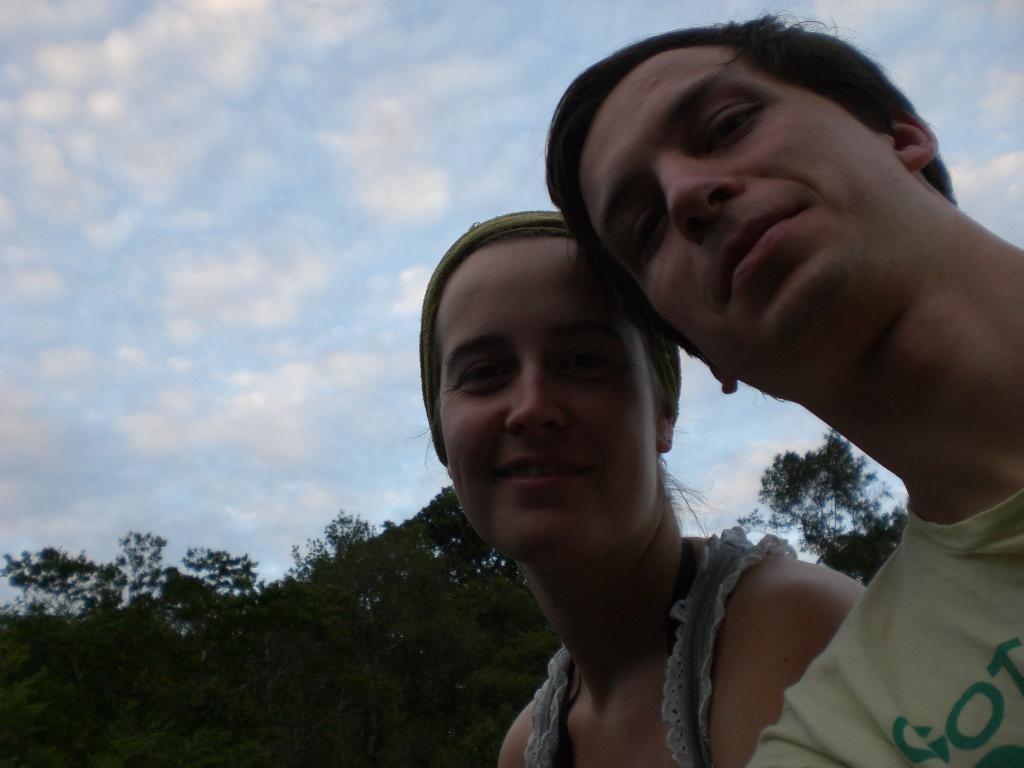In one or two sentences, can you explain what this image depicts? In this image there are two persons, few trees and some clouds in the sky. 